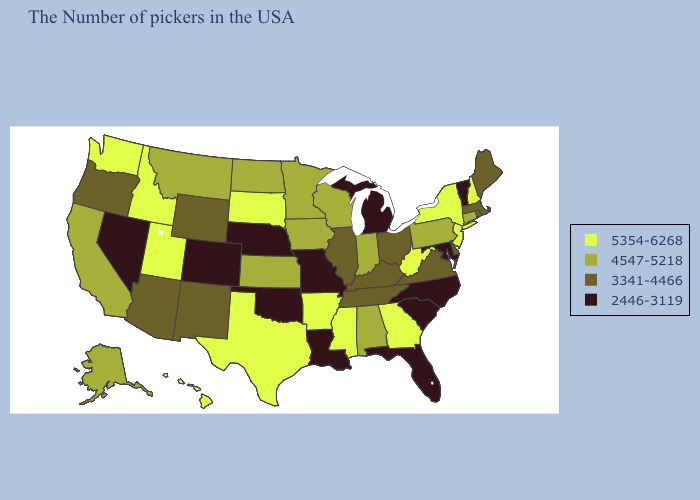What is the value of Arkansas?
Answer briefly. 5354-6268. Does Connecticut have a lower value than Oregon?
Keep it brief. No. Name the states that have a value in the range 5354-6268?
Quick response, please. New Hampshire, New York, New Jersey, West Virginia, Georgia, Mississippi, Arkansas, Texas, South Dakota, Utah, Idaho, Washington, Hawaii. What is the highest value in states that border New York?
Short answer required. 5354-6268. What is the value of New Mexico?
Be succinct. 3341-4466. Among the states that border North Carolina , which have the lowest value?
Write a very short answer. South Carolina. What is the value of New Hampshire?
Write a very short answer. 5354-6268. Among the states that border Minnesota , which have the highest value?
Concise answer only. South Dakota. What is the highest value in the USA?
Write a very short answer. 5354-6268. Among the states that border Wisconsin , does Illinois have the lowest value?
Be succinct. No. What is the lowest value in states that border Alabama?
Be succinct. 2446-3119. What is the value of Colorado?
Give a very brief answer. 2446-3119. Among the states that border Colorado , does Utah have the highest value?
Write a very short answer. Yes. Which states have the lowest value in the USA?
Give a very brief answer. Vermont, Maryland, North Carolina, South Carolina, Florida, Michigan, Louisiana, Missouri, Nebraska, Oklahoma, Colorado, Nevada. Does Kansas have the lowest value in the USA?
Quick response, please. No. 